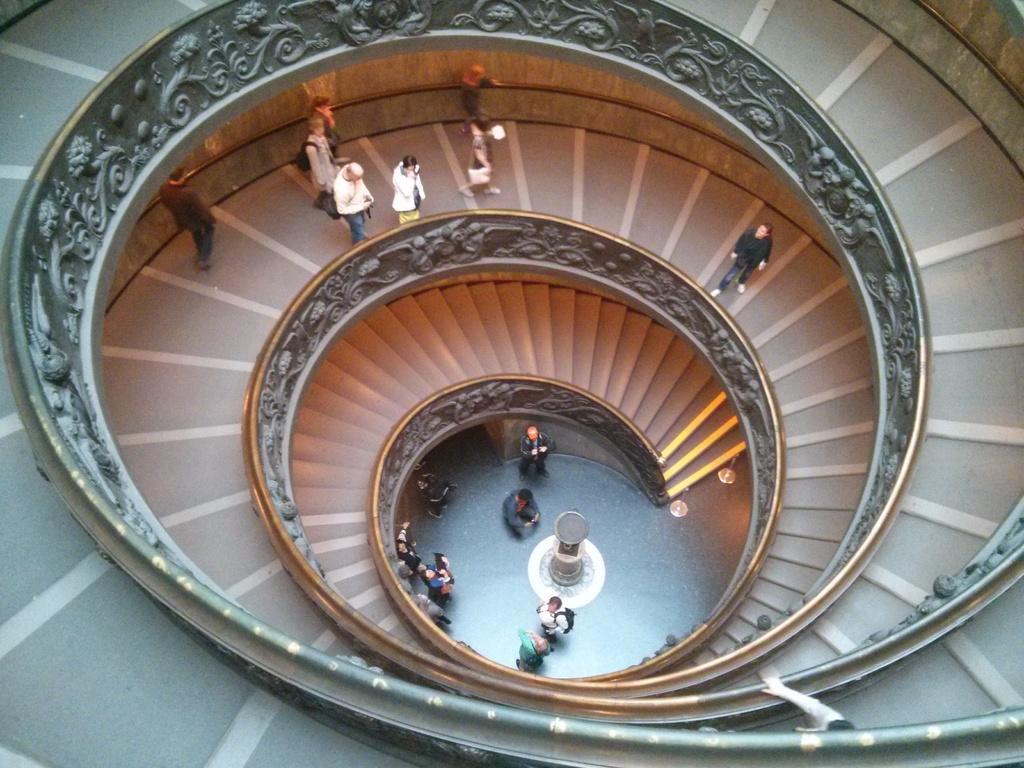How would you summarize this image in a sentence or two? There are steps in the shape of spiral. There are many people on the steps. On the side of the steps there is a small wall with some art on it. 